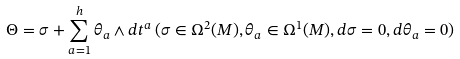Convert formula to latex. <formula><loc_0><loc_0><loc_500><loc_500>\Theta = \sigma + \sum _ { a = 1 } ^ { h } \theta _ { a } \wedge d t ^ { a } \, ( \sigma \in \Omega ^ { 2 } ( M ) , \theta _ { a } \in \Omega ^ { 1 } ( M ) , d \sigma = 0 , d \theta _ { a } = 0 )</formula> 